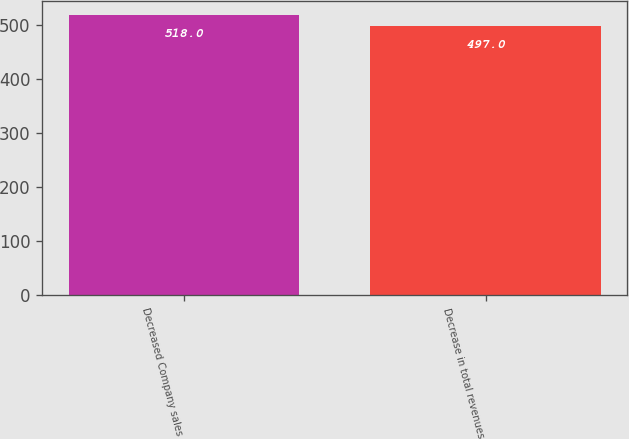Convert chart. <chart><loc_0><loc_0><loc_500><loc_500><bar_chart><fcel>Decreased Company sales<fcel>Decrease in total revenues<nl><fcel>518<fcel>497<nl></chart> 